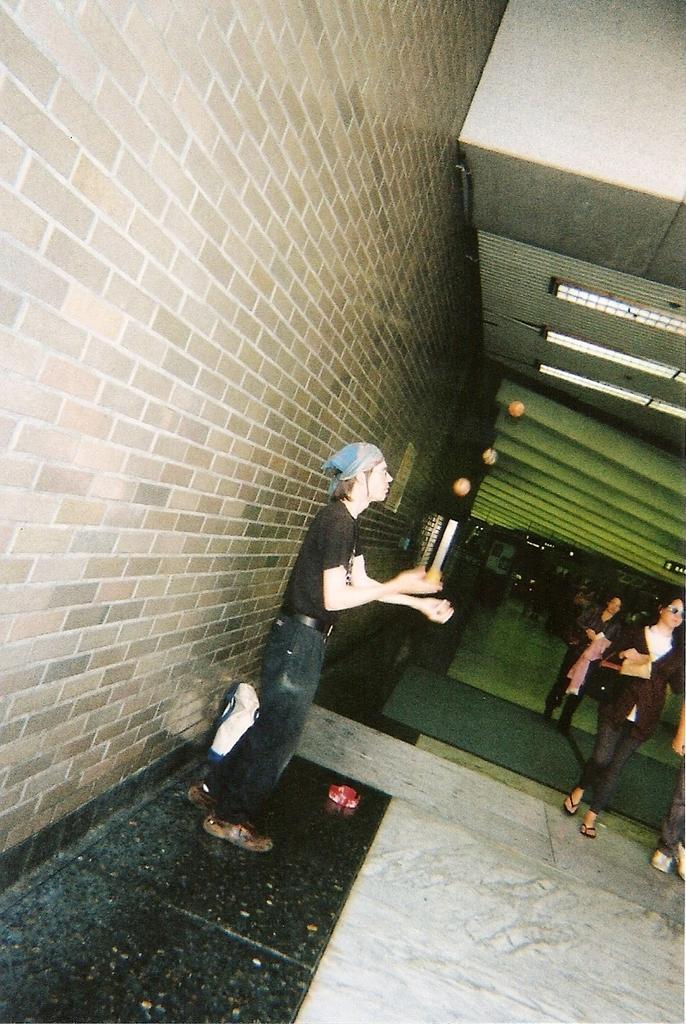In one or two sentences, can you explain what this image depicts? This picture shows few people entering into the building and we see a man standing and playing with the balls and he wore a cloth to his head and we see a woman wore a sunglasses on her face and she is carrying a handbag and we see few lights to the roof. 